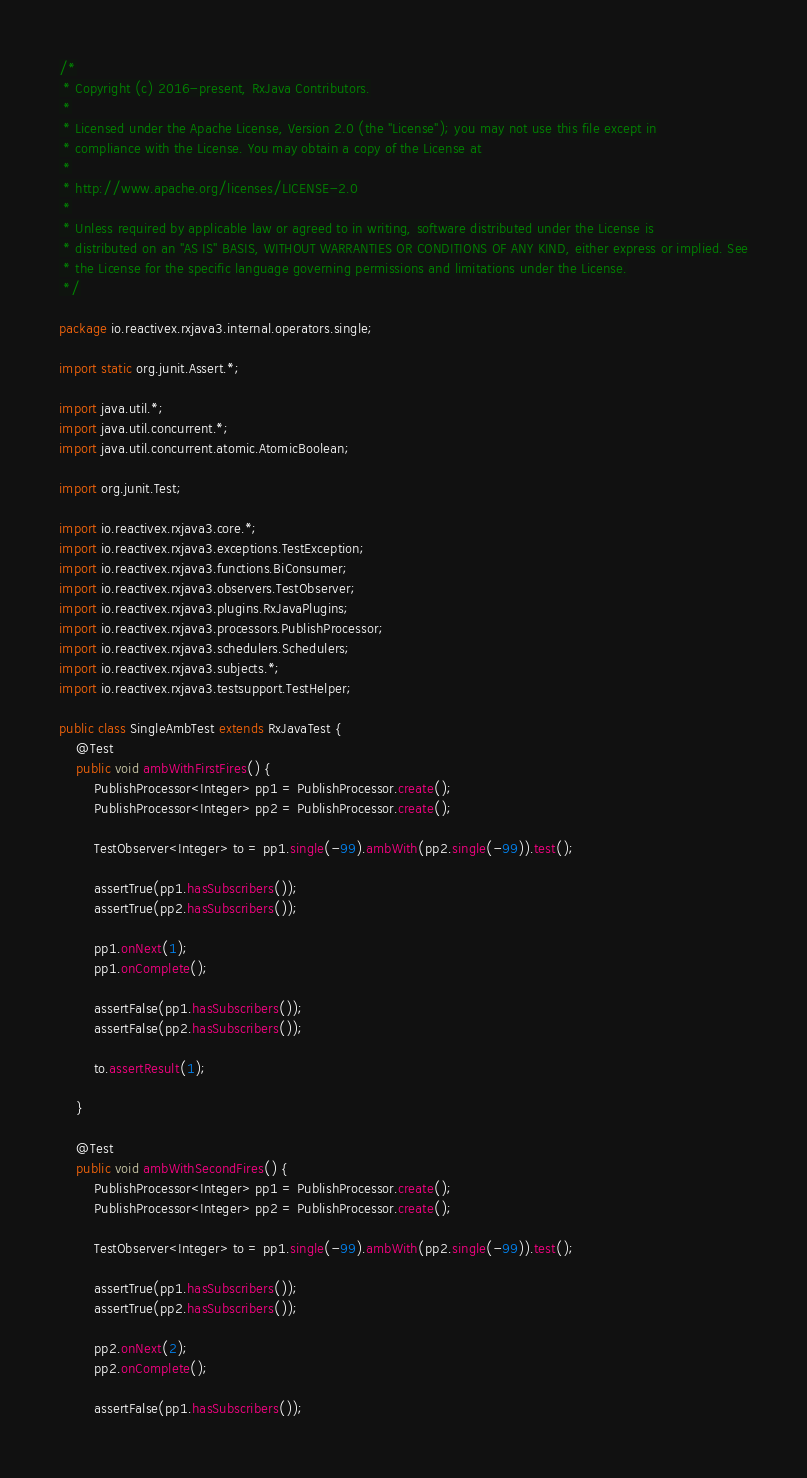Convert code to text. <code><loc_0><loc_0><loc_500><loc_500><_Java_>/*
 * Copyright (c) 2016-present, RxJava Contributors.
 *
 * Licensed under the Apache License, Version 2.0 (the "License"); you may not use this file except in
 * compliance with the License. You may obtain a copy of the License at
 *
 * http://www.apache.org/licenses/LICENSE-2.0
 *
 * Unless required by applicable law or agreed to in writing, software distributed under the License is
 * distributed on an "AS IS" BASIS, WITHOUT WARRANTIES OR CONDITIONS OF ANY KIND, either express or implied. See
 * the License for the specific language governing permissions and limitations under the License.
 */

package io.reactivex.rxjava3.internal.operators.single;

import static org.junit.Assert.*;

import java.util.*;
import java.util.concurrent.*;
import java.util.concurrent.atomic.AtomicBoolean;

import org.junit.Test;

import io.reactivex.rxjava3.core.*;
import io.reactivex.rxjava3.exceptions.TestException;
import io.reactivex.rxjava3.functions.BiConsumer;
import io.reactivex.rxjava3.observers.TestObserver;
import io.reactivex.rxjava3.plugins.RxJavaPlugins;
import io.reactivex.rxjava3.processors.PublishProcessor;
import io.reactivex.rxjava3.schedulers.Schedulers;
import io.reactivex.rxjava3.subjects.*;
import io.reactivex.rxjava3.testsupport.TestHelper;

public class SingleAmbTest extends RxJavaTest {
    @Test
    public void ambWithFirstFires() {
        PublishProcessor<Integer> pp1 = PublishProcessor.create();
        PublishProcessor<Integer> pp2 = PublishProcessor.create();

        TestObserver<Integer> to = pp1.single(-99).ambWith(pp2.single(-99)).test();

        assertTrue(pp1.hasSubscribers());
        assertTrue(pp2.hasSubscribers());

        pp1.onNext(1);
        pp1.onComplete();

        assertFalse(pp1.hasSubscribers());
        assertFalse(pp2.hasSubscribers());

        to.assertResult(1);

    }

    @Test
    public void ambWithSecondFires() {
        PublishProcessor<Integer> pp1 = PublishProcessor.create();
        PublishProcessor<Integer> pp2 = PublishProcessor.create();

        TestObserver<Integer> to = pp1.single(-99).ambWith(pp2.single(-99)).test();

        assertTrue(pp1.hasSubscribers());
        assertTrue(pp2.hasSubscribers());

        pp2.onNext(2);
        pp2.onComplete();

        assertFalse(pp1.hasSubscribers());</code> 